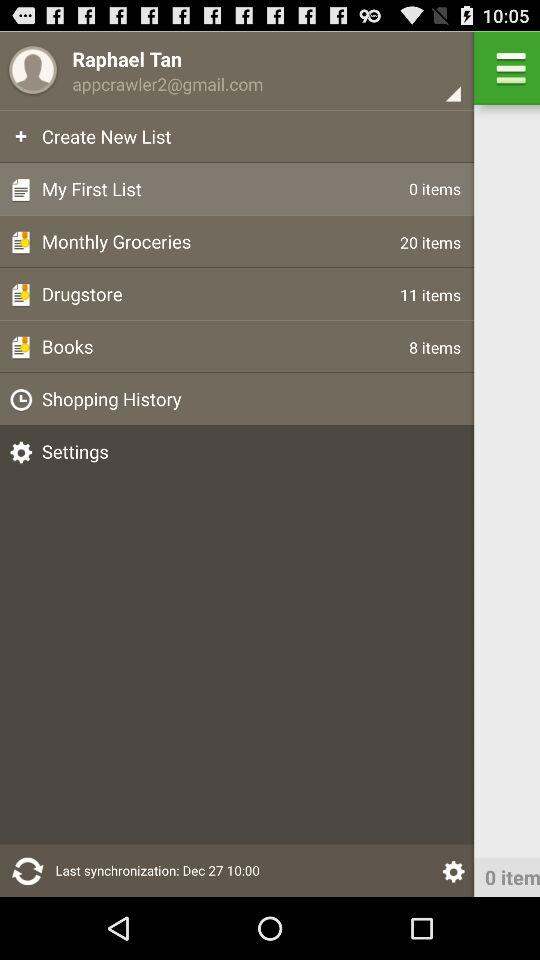How many items are there in Books? There are 8 items in Books. 